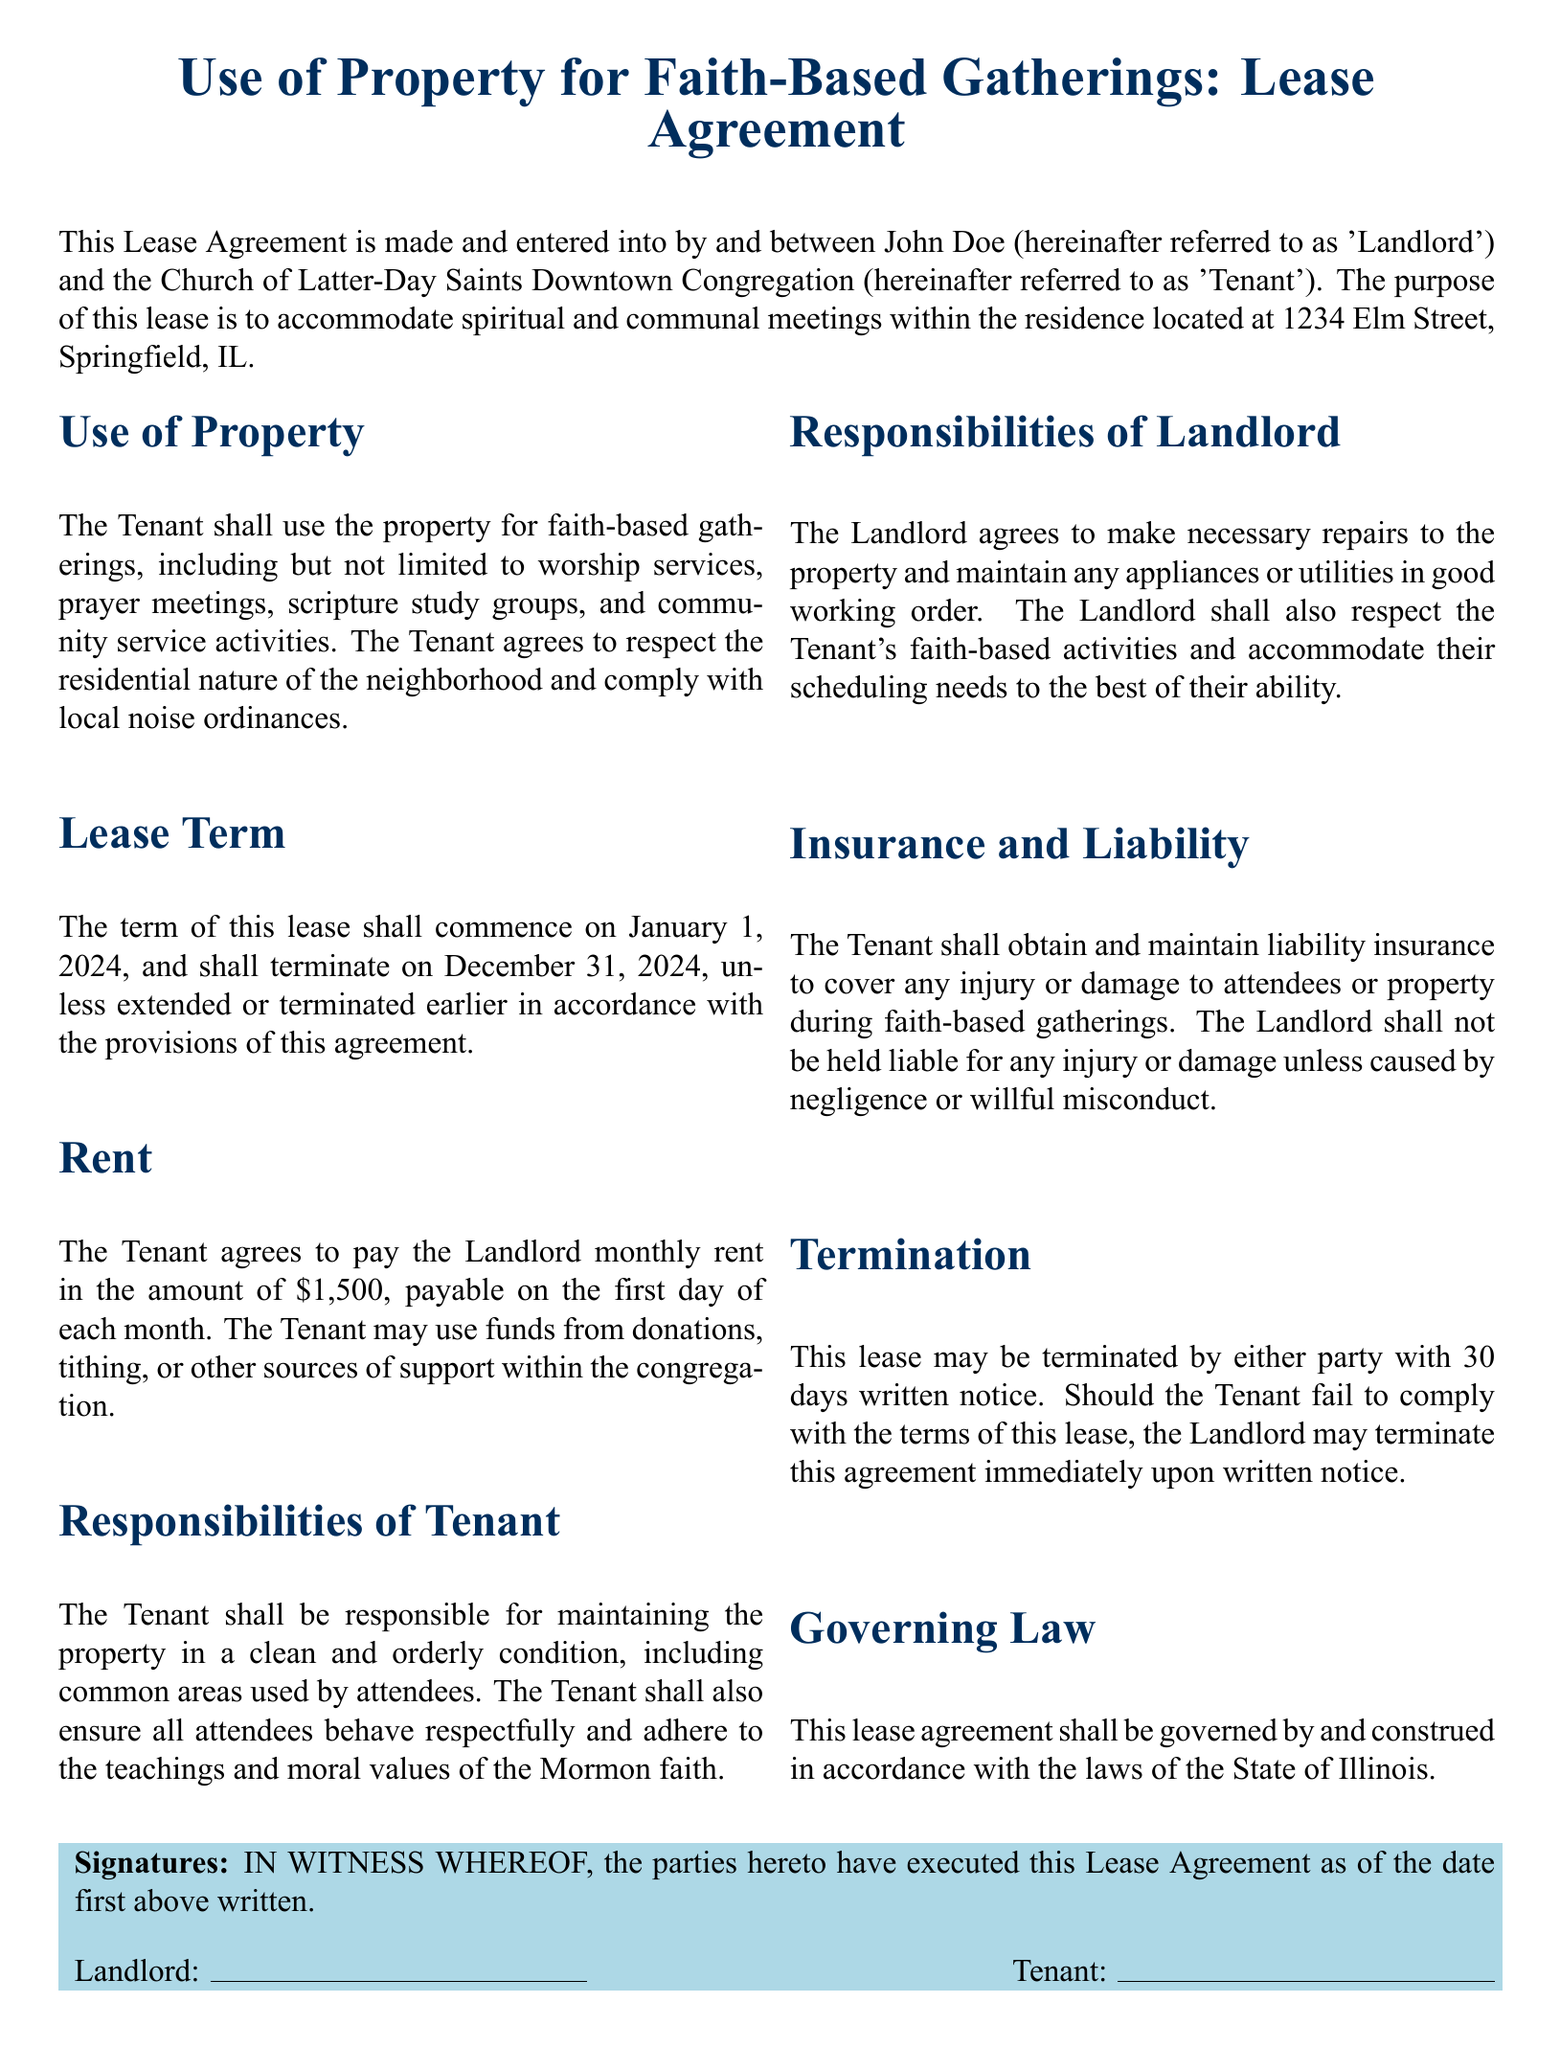What is the address of the property? The address of the property is listed as 1234 Elm Street, Springfield, IL.
Answer: 1234 Elm Street, Springfield, IL Who is the landlord in the agreement? The lease agreement identifies John Doe as the landlord.
Answer: John Doe What is the monthly rent amount? The monthly rent amount specified in the lease is $1,500.
Answer: $1,500 What is the lease term duration? The lease term begins on January 1, 2024, and ends on December 31, 2024, making it a one-year duration.
Answer: One year How much notice is required to terminate the lease? The lease specifies that a 30-day written notice is required for termination by either party.
Answer: 30 days What type of insurance must the tenant obtain? The tenant is required to obtain liability insurance during faith-based gatherings.
Answer: Liability insurance Who is responsible for repairs to the property? The landlord agrees to make necessary repairs to the property.
Answer: Landlord What are the tenant's responsibilities regarding attendees? The tenant must ensure all attendees behave respectfully and adhere to the teachings of the Mormon faith.
Answer: Respectful behavior Which laws govern the lease agreement? The lease agreement states it shall be governed by the laws of the State of Illinois.
Answer: State of Illinois 